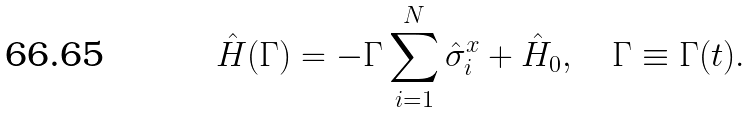<formula> <loc_0><loc_0><loc_500><loc_500>\hat { H } ( \Gamma ) = - \Gamma \sum _ { i = 1 } ^ { N } \hat { \sigma } _ { i } ^ { x } + \hat { H } _ { 0 } , \quad \Gamma \equiv \Gamma ( t ) .</formula> 